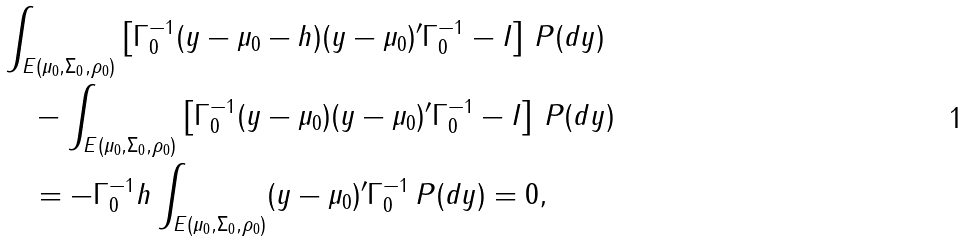<formula> <loc_0><loc_0><loc_500><loc_500>& \int _ { E ( \mu _ { 0 } , \Sigma _ { 0 } , \rho _ { 0 } ) } \left [ \Gamma _ { 0 } ^ { - 1 } ( y - \mu _ { 0 } - h ) ( y - \mu _ { 0 } ) ^ { \prime } \Gamma _ { 0 } ^ { - 1 } - I \right ] \, P ( d y ) \\ & \quad - \int _ { E ( \mu _ { 0 } , \Sigma _ { 0 } , \rho _ { 0 } ) } \left [ \Gamma _ { 0 } ^ { - 1 } ( y - \mu _ { 0 } ) ( y - \mu _ { 0 } ) ^ { \prime } \Gamma _ { 0 } ^ { - 1 } - I \right ] \, P ( d y ) \\ & \quad = - \Gamma _ { 0 } ^ { - 1 } h \int _ { E ( \mu _ { 0 } , \Sigma _ { 0 } , \rho _ { 0 } ) } ( y - \mu _ { 0 } ) ^ { \prime } \Gamma _ { 0 } ^ { - 1 } \, P ( d y ) = 0 ,</formula> 